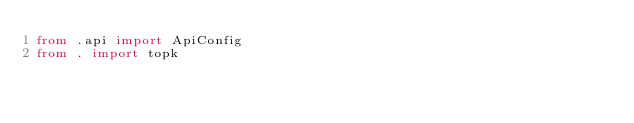Convert code to text. <code><loc_0><loc_0><loc_500><loc_500><_Python_>from .api import ApiConfig
from . import topk
</code> 